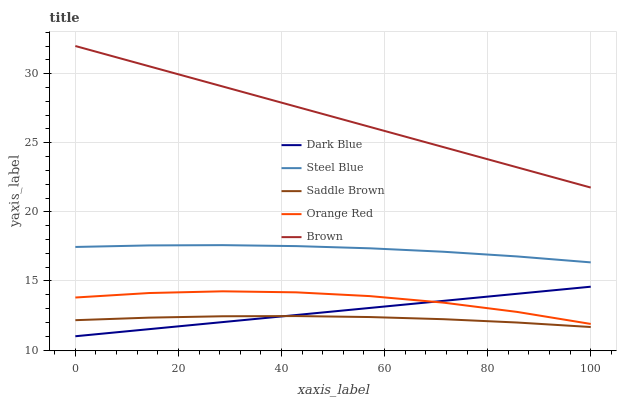Does Saddle Brown have the minimum area under the curve?
Answer yes or no. Yes. Does Brown have the maximum area under the curve?
Answer yes or no. Yes. Does Dark Blue have the minimum area under the curve?
Answer yes or no. No. Does Dark Blue have the maximum area under the curve?
Answer yes or no. No. Is Brown the smoothest?
Answer yes or no. Yes. Is Orange Red the roughest?
Answer yes or no. Yes. Is Dark Blue the smoothest?
Answer yes or no. No. Is Dark Blue the roughest?
Answer yes or no. No. Does Steel Blue have the lowest value?
Answer yes or no. No. Does Brown have the highest value?
Answer yes or no. Yes. Does Dark Blue have the highest value?
Answer yes or no. No. Is Saddle Brown less than Brown?
Answer yes or no. Yes. Is Steel Blue greater than Saddle Brown?
Answer yes or no. Yes. Does Dark Blue intersect Orange Red?
Answer yes or no. Yes. Is Dark Blue less than Orange Red?
Answer yes or no. No. Is Dark Blue greater than Orange Red?
Answer yes or no. No. Does Saddle Brown intersect Brown?
Answer yes or no. No. 